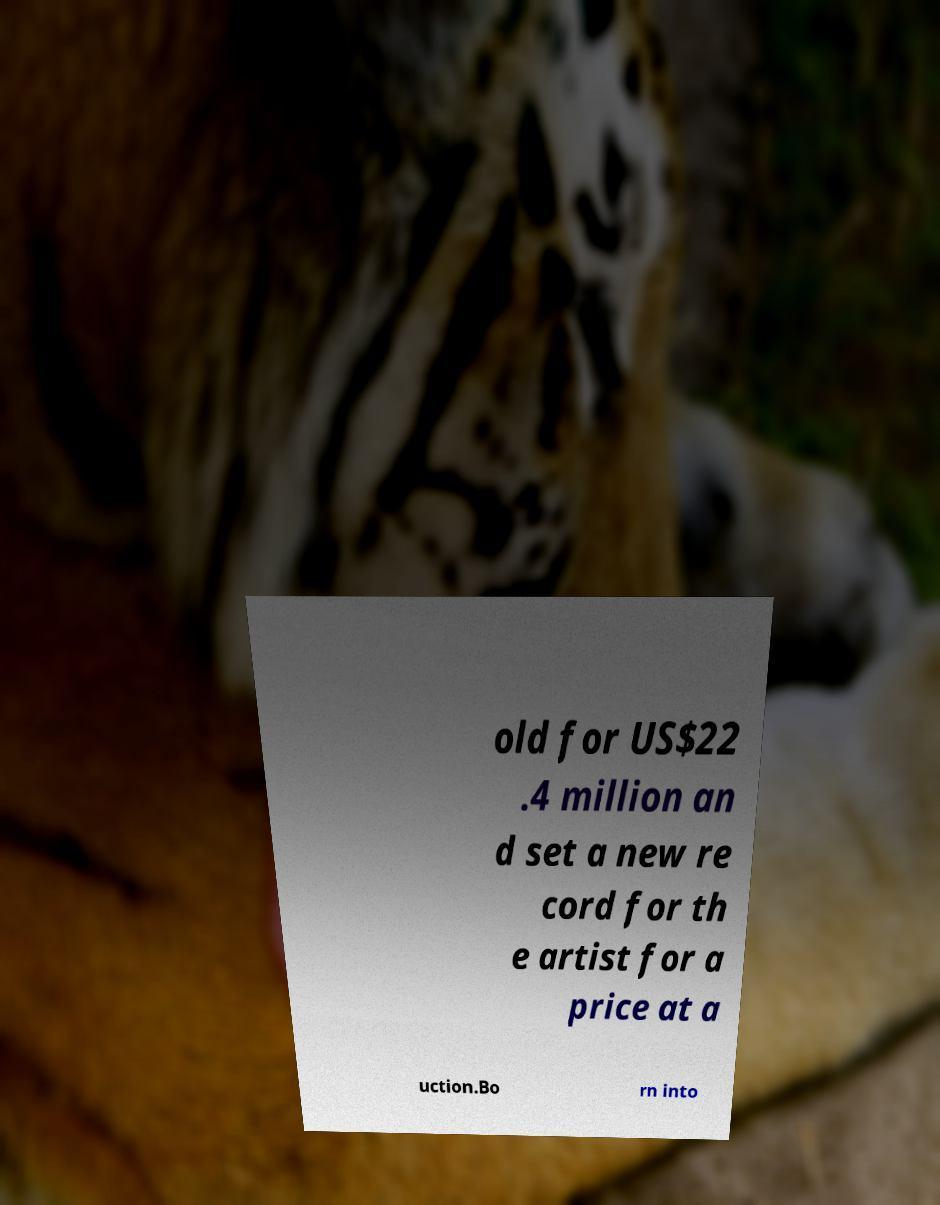Could you assist in decoding the text presented in this image and type it out clearly? old for US$22 .4 million an d set a new re cord for th e artist for a price at a uction.Bo rn into 